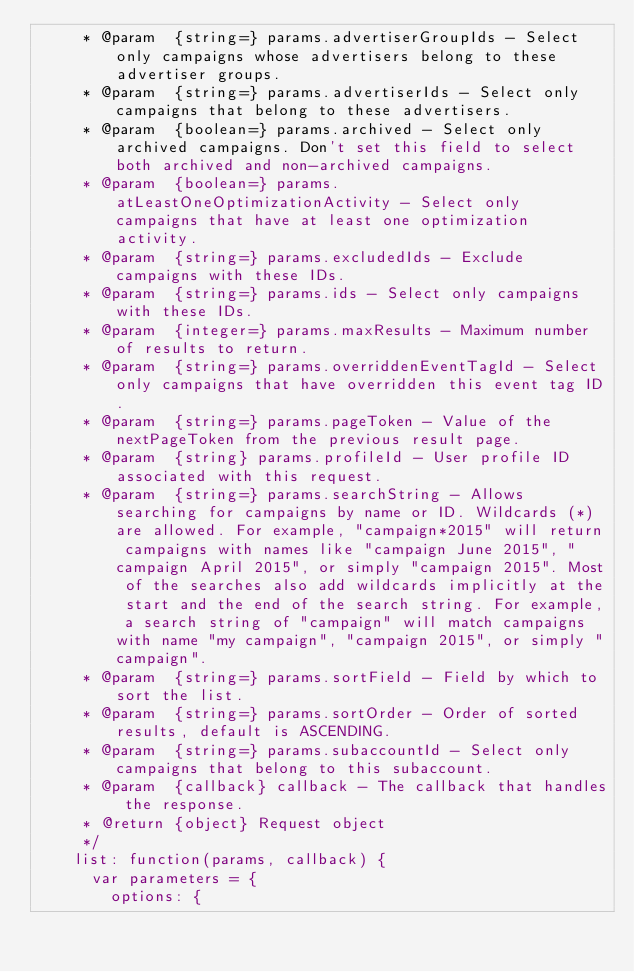Convert code to text. <code><loc_0><loc_0><loc_500><loc_500><_JavaScript_>     * @param  {string=} params.advertiserGroupIds - Select only campaigns whose advertisers belong to these advertiser groups.
     * @param  {string=} params.advertiserIds - Select only campaigns that belong to these advertisers.
     * @param  {boolean=} params.archived - Select only archived campaigns. Don't set this field to select both archived and non-archived campaigns.
     * @param  {boolean=} params.atLeastOneOptimizationActivity - Select only campaigns that have at least one optimization activity.
     * @param  {string=} params.excludedIds - Exclude campaigns with these IDs.
     * @param  {string=} params.ids - Select only campaigns with these IDs.
     * @param  {integer=} params.maxResults - Maximum number of results to return.
     * @param  {string=} params.overriddenEventTagId - Select only campaigns that have overridden this event tag ID.
     * @param  {string=} params.pageToken - Value of the nextPageToken from the previous result page.
     * @param  {string} params.profileId - User profile ID associated with this request.
     * @param  {string=} params.searchString - Allows searching for campaigns by name or ID. Wildcards (*) are allowed. For example, "campaign*2015" will return campaigns with names like "campaign June 2015", "campaign April 2015", or simply "campaign 2015". Most of the searches also add wildcards implicitly at the start and the end of the search string. For example, a search string of "campaign" will match campaigns with name "my campaign", "campaign 2015", or simply "campaign".
     * @param  {string=} params.sortField - Field by which to sort the list.
     * @param  {string=} params.sortOrder - Order of sorted results, default is ASCENDING.
     * @param  {string=} params.subaccountId - Select only campaigns that belong to this subaccount.
     * @param  {callback} callback - The callback that handles the response.
     * @return {object} Request object
     */
    list: function(params, callback) {
      var parameters = {
        options: {</code> 